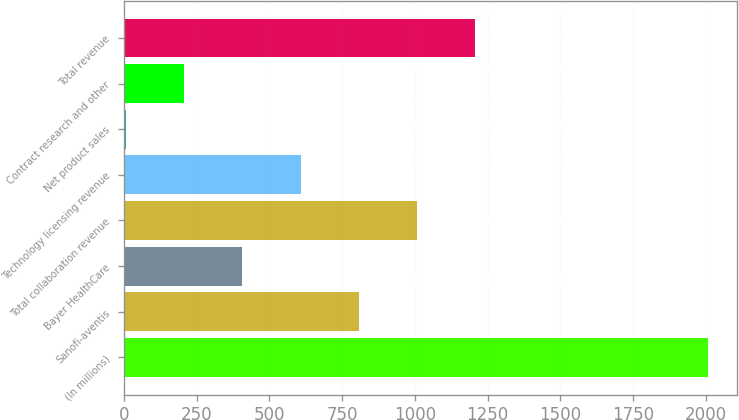<chart> <loc_0><loc_0><loc_500><loc_500><bar_chart><fcel>(In millions)<fcel>Sanofi-aventis<fcel>Bayer HealthCare<fcel>Total collaboration revenue<fcel>Technology licensing revenue<fcel>Net product sales<fcel>Contract research and other<fcel>Total revenue<nl><fcel>2008<fcel>806.98<fcel>406.64<fcel>1007.15<fcel>606.81<fcel>6.3<fcel>206.47<fcel>1207.32<nl></chart> 